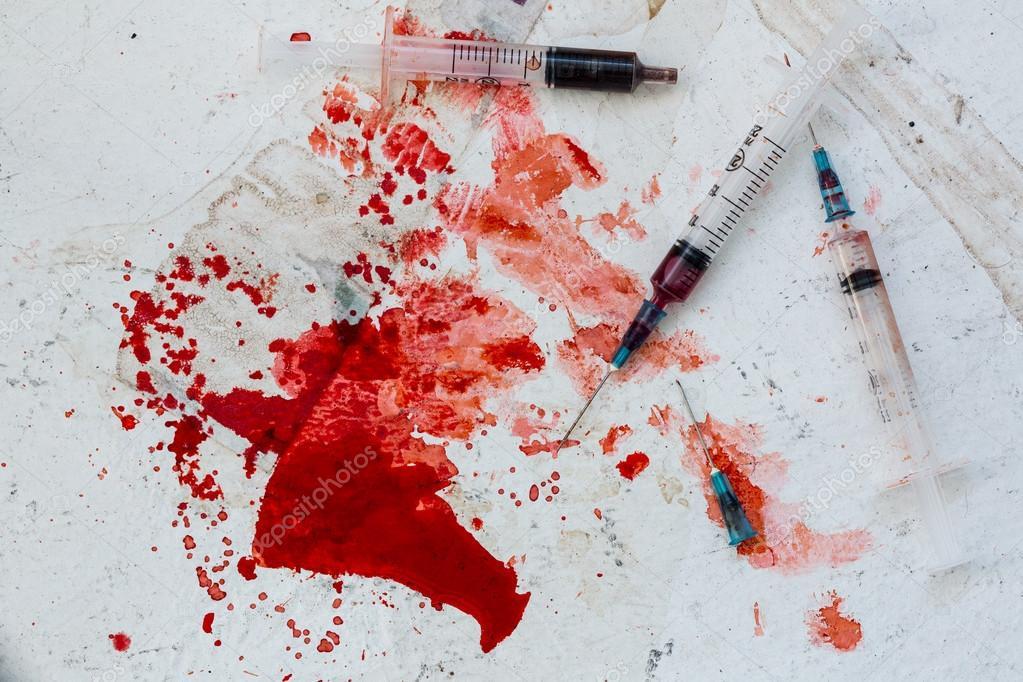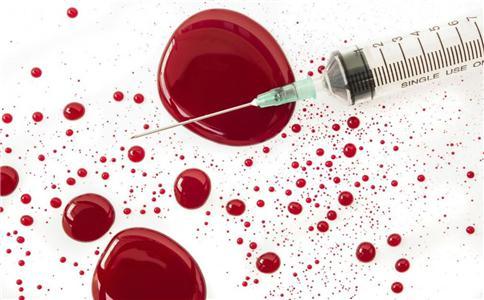The first image is the image on the left, the second image is the image on the right. Given the left and right images, does the statement "There are needles with red liquid and two hands." hold true? Answer yes or no. No. The first image is the image on the left, the second image is the image on the right. Assess this claim about the two images: "A gloved hand holds an uncapped syringe in one image.". Correct or not? Answer yes or no. No. 